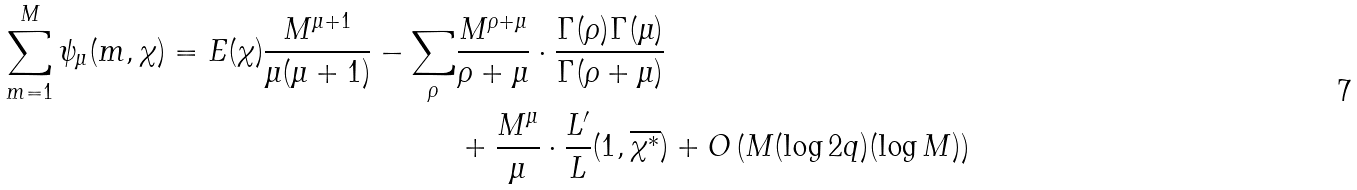<formula> <loc_0><loc_0><loc_500><loc_500>\sum _ { m = 1 } ^ { M } \psi _ { \mu } ( m , \chi ) = E ( \chi ) \frac { M ^ { \mu + 1 } } { \mu ( \mu + 1 ) } - \sum _ { \rho } & \frac { M ^ { \rho + \mu } } { \rho + \mu } \cdot \frac { \Gamma ( \rho ) \Gamma ( \mu ) } { \Gamma ( \rho + \mu ) } \\ & + \frac { M ^ { \mu } } { \mu } \cdot \frac { L ^ { \prime } } { L } ( 1 , \overline { \chi ^ { \ast } } ) + O \left ( M ( \log 2 q ) ( \log M ) \right )</formula> 